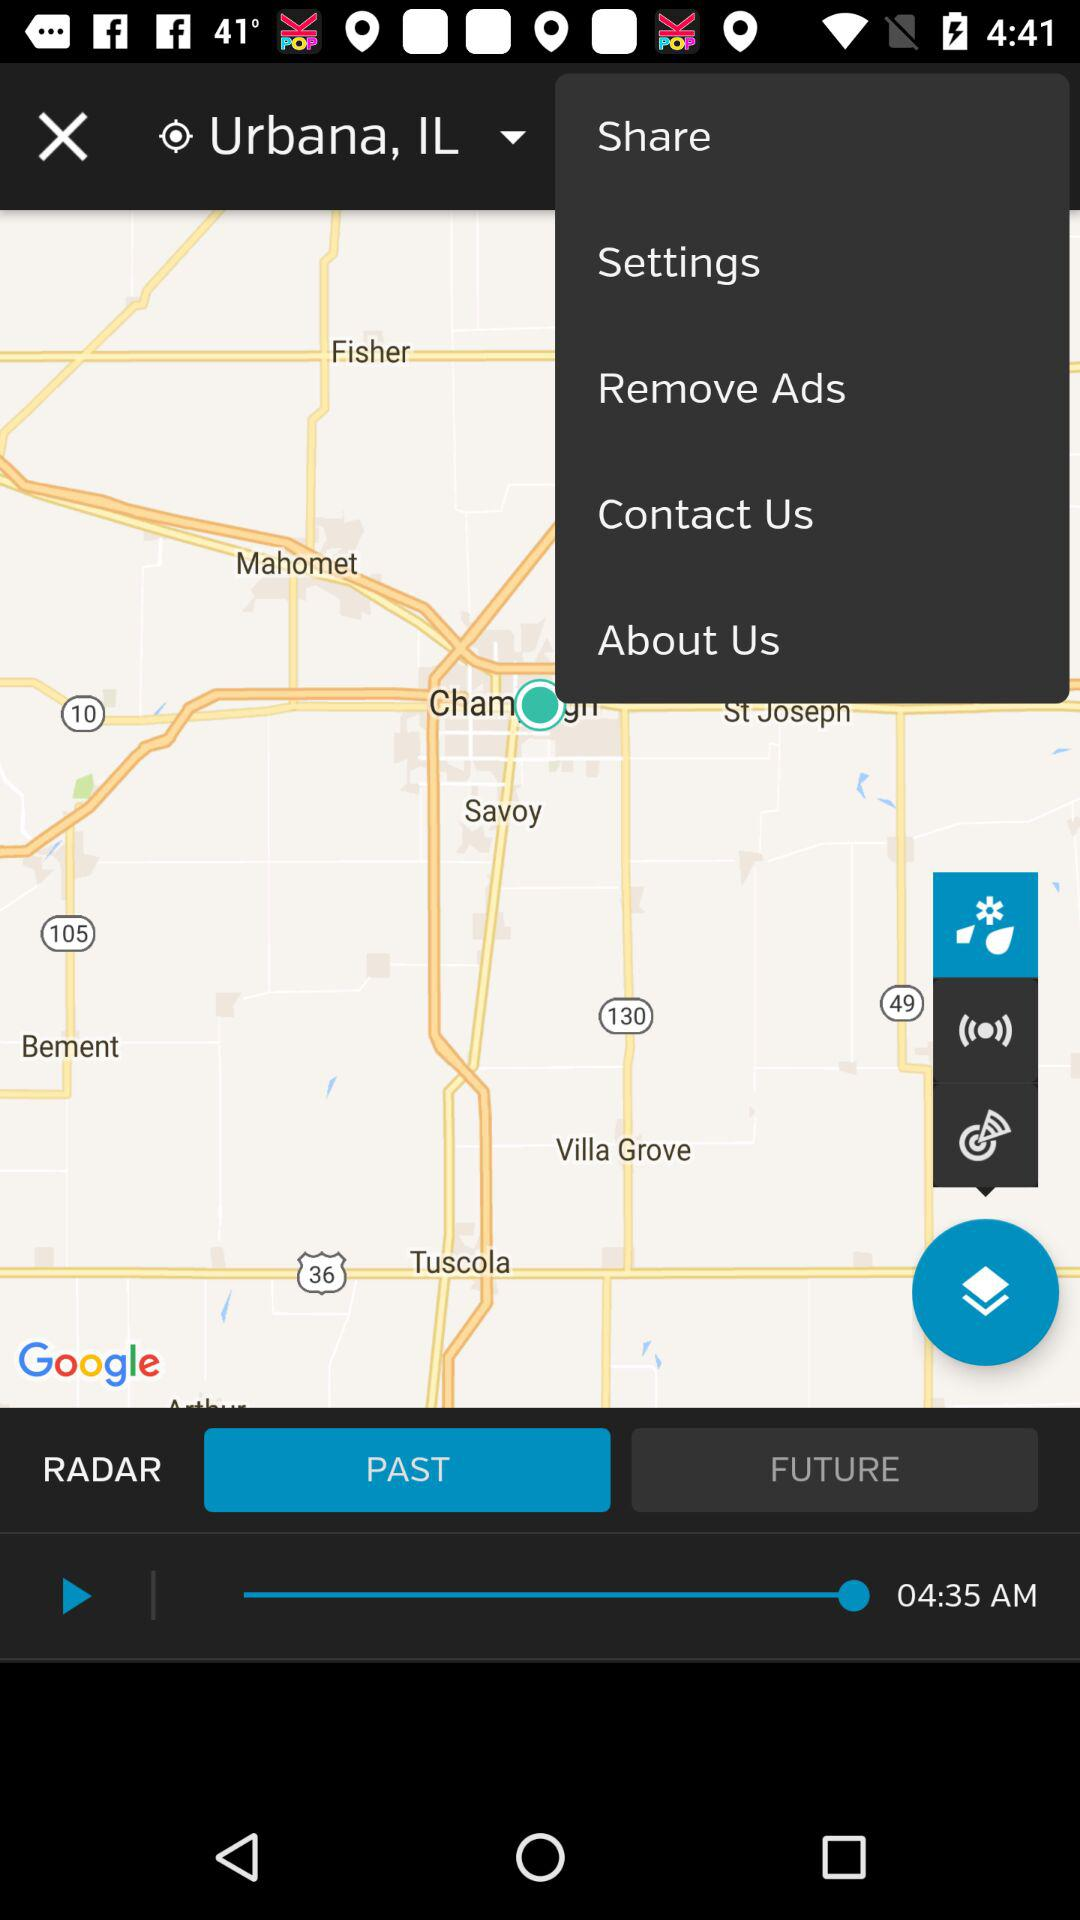What is the location? The location is Urbana, IL. 